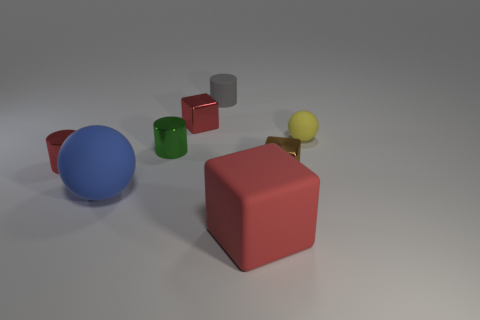Add 1 big objects. How many objects exist? 9 Subtract all balls. How many objects are left? 6 Add 7 brown metal things. How many brown metal things are left? 8 Add 5 shiny things. How many shiny things exist? 9 Subtract 0 purple cylinders. How many objects are left? 8 Subtract all big matte spheres. Subtract all big blue rubber objects. How many objects are left? 6 